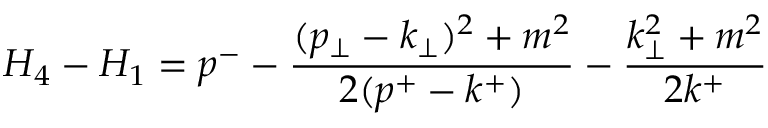Convert formula to latex. <formula><loc_0><loc_0><loc_500><loc_500>H _ { 4 } - H _ { 1 } = p ^ { - } - \frac { ( p _ { \perp } - k _ { \perp } ) ^ { 2 } + m ^ { 2 } } { 2 ( p ^ { + } - k ^ { + } ) } - \frac { k _ { \perp } ^ { 2 } + m ^ { 2 } } { 2 k ^ { + } }</formula> 